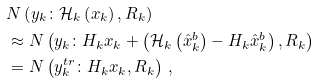Convert formula to latex. <formula><loc_0><loc_0><loc_500><loc_500>& N \left ( y _ { k } \colon \mathcal { H } _ { k } \left ( x _ { k } \right ) , R _ { k } \right ) \\ & \approx N \left ( y _ { k } \colon H _ { k } x _ { k } + \left ( \mathcal { H } _ { k } \left ( \hat { x } _ { k } ^ { b } \right ) - H _ { k } \hat { x } _ { k } ^ { b } \right ) , R _ { k } \right ) \\ & = N \left ( y _ { k } ^ { t r } \colon H _ { k } x _ { k } , R _ { k } \right ) \, ,</formula> 